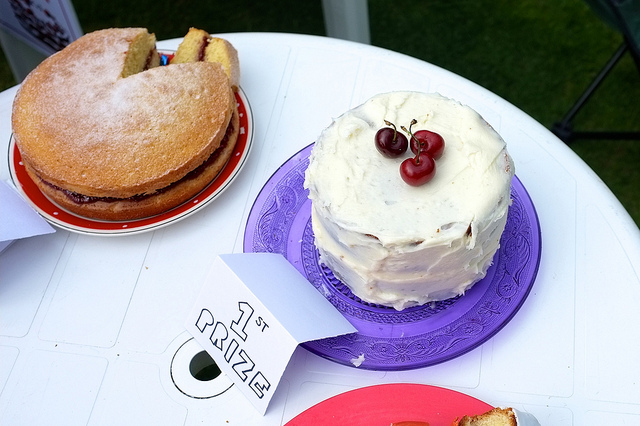Read and extract the text from this image. 1 ST PRIZE 